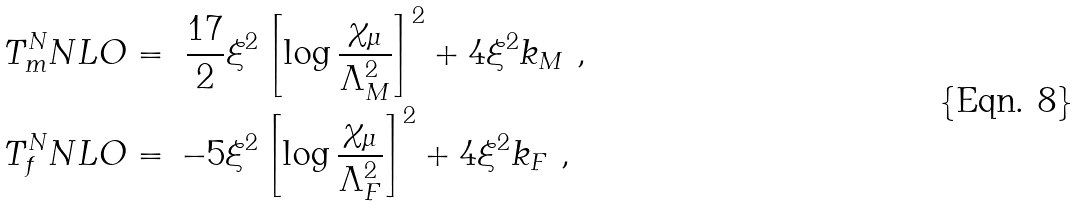<formula> <loc_0><loc_0><loc_500><loc_500>T _ { m } ^ { N } N L O & = \ \frac { 1 7 } { 2 } \xi ^ { 2 } \left [ \log \frac { \chi _ { \mu } } { \Lambda _ { M } ^ { 2 } } \right ] ^ { 2 } + 4 \xi ^ { 2 } k _ { M } \ , \\ T _ { f } ^ { N } N L O & = \, - 5 \xi ^ { 2 } \left [ \log \frac { \chi _ { \mu } } { \Lambda _ { F } ^ { 2 } } \right ] ^ { 2 } + 4 \xi ^ { 2 } k _ { F } \ , \\</formula> 